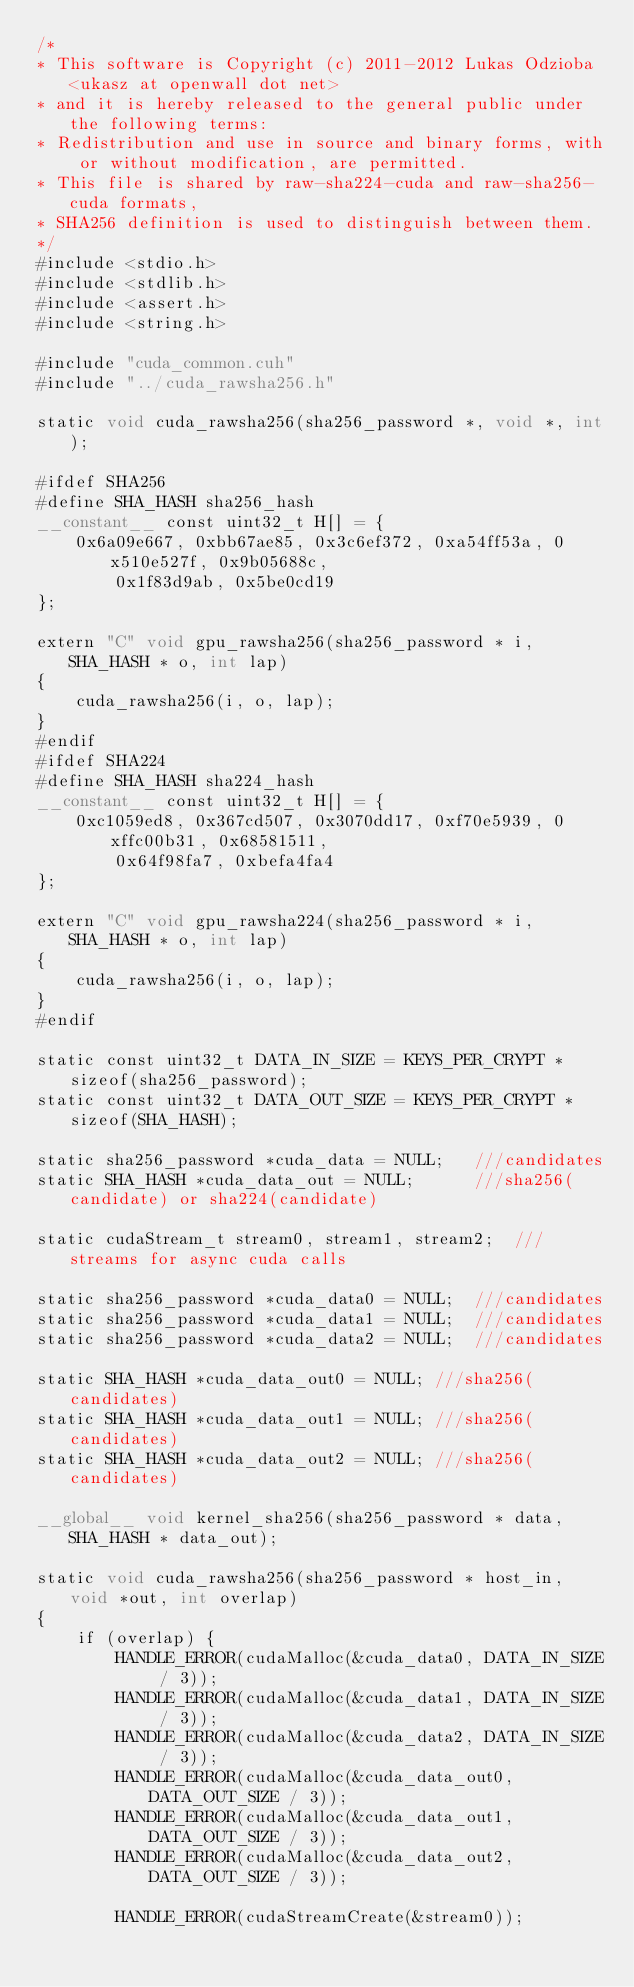Convert code to text. <code><loc_0><loc_0><loc_500><loc_500><_Cuda_>/*
* This software is Copyright (c) 2011-2012 Lukas Odzioba <ukasz at openwall dot net>
* and it is hereby released to the general public under the following terms:
* Redistribution and use in source and binary forms, with or without modification, are permitted.
* This file is shared by raw-sha224-cuda and raw-sha256-cuda formats,
* SHA256 definition is used to distinguish between them.
*/
#include <stdio.h>
#include <stdlib.h>
#include <assert.h>
#include <string.h>

#include "cuda_common.cuh"
#include "../cuda_rawsha256.h"

static void cuda_rawsha256(sha256_password *, void *, int);

#ifdef SHA256
#define SHA_HASH sha256_hash
__constant__ const uint32_t H[] = {
	0x6a09e667, 0xbb67ae85, 0x3c6ef372, 0xa54ff53a, 0x510e527f, 0x9b05688c,
	    0x1f83d9ab, 0x5be0cd19
};

extern "C" void gpu_rawsha256(sha256_password * i, SHA_HASH * o, int lap)
{
	cuda_rawsha256(i, o, lap);
}
#endif
#ifdef SHA224
#define SHA_HASH sha224_hash
__constant__ const uint32_t H[] = {
	0xc1059ed8, 0x367cd507, 0x3070dd17, 0xf70e5939, 0xffc00b31, 0x68581511,
	    0x64f98fa7, 0xbefa4fa4
};

extern "C" void gpu_rawsha224(sha256_password * i, SHA_HASH * o, int lap)
{
	cuda_rawsha256(i, o, lap);
}
#endif

static const uint32_t DATA_IN_SIZE = KEYS_PER_CRYPT * sizeof(sha256_password);
static const uint32_t DATA_OUT_SIZE = KEYS_PER_CRYPT * sizeof(SHA_HASH);

static sha256_password *cuda_data = NULL;	///candidates
static SHA_HASH *cuda_data_out = NULL;		///sha256(candidate) or sha224(candidate)

static cudaStream_t stream0, stream1, stream2;	///streams for async cuda calls

static sha256_password *cuda_data0 = NULL;	///candidates
static sha256_password *cuda_data1 = NULL;	///candidates
static sha256_password *cuda_data2 = NULL;	///candidates

static SHA_HASH *cuda_data_out0 = NULL;	///sha256(candidates)
static SHA_HASH *cuda_data_out1 = NULL;	///sha256(candidates)
static SHA_HASH *cuda_data_out2 = NULL;	///sha256(candidates)

__global__ void kernel_sha256(sha256_password * data, SHA_HASH * data_out);

static void cuda_rawsha256(sha256_password * host_in, void *out, int overlap)
{
	if (overlap) {
		HANDLE_ERROR(cudaMalloc(&cuda_data0, DATA_IN_SIZE / 3));
		HANDLE_ERROR(cudaMalloc(&cuda_data1, DATA_IN_SIZE / 3));
		HANDLE_ERROR(cudaMalloc(&cuda_data2, DATA_IN_SIZE / 3));
		HANDLE_ERROR(cudaMalloc(&cuda_data_out0, DATA_OUT_SIZE / 3));
		HANDLE_ERROR(cudaMalloc(&cuda_data_out1, DATA_OUT_SIZE / 3));
		HANDLE_ERROR(cudaMalloc(&cuda_data_out2, DATA_OUT_SIZE / 3));

		HANDLE_ERROR(cudaStreamCreate(&stream0));</code> 